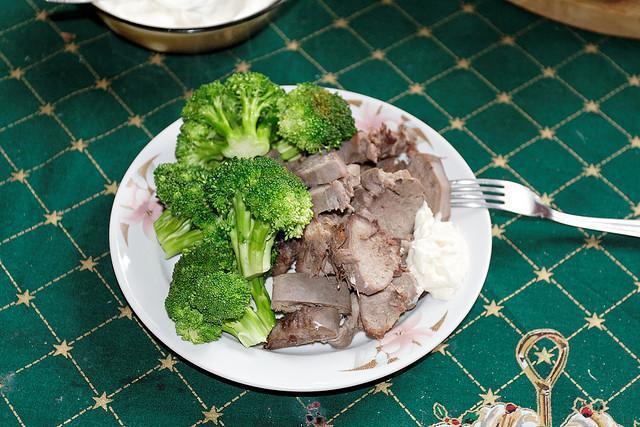How many bowls are there?
Give a very brief answer. 2. How many broccolis can you see?
Give a very brief answer. 5. 